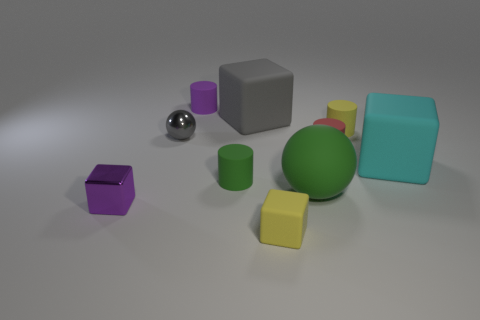Subtract 1 blocks. How many blocks are left? 3 Subtract all cubes. How many objects are left? 6 Subtract all gray balls. Subtract all small green matte objects. How many objects are left? 8 Add 1 gray balls. How many gray balls are left? 2 Add 3 large cyan metallic balls. How many large cyan metallic balls exist? 3 Subtract 0 red cubes. How many objects are left? 10 